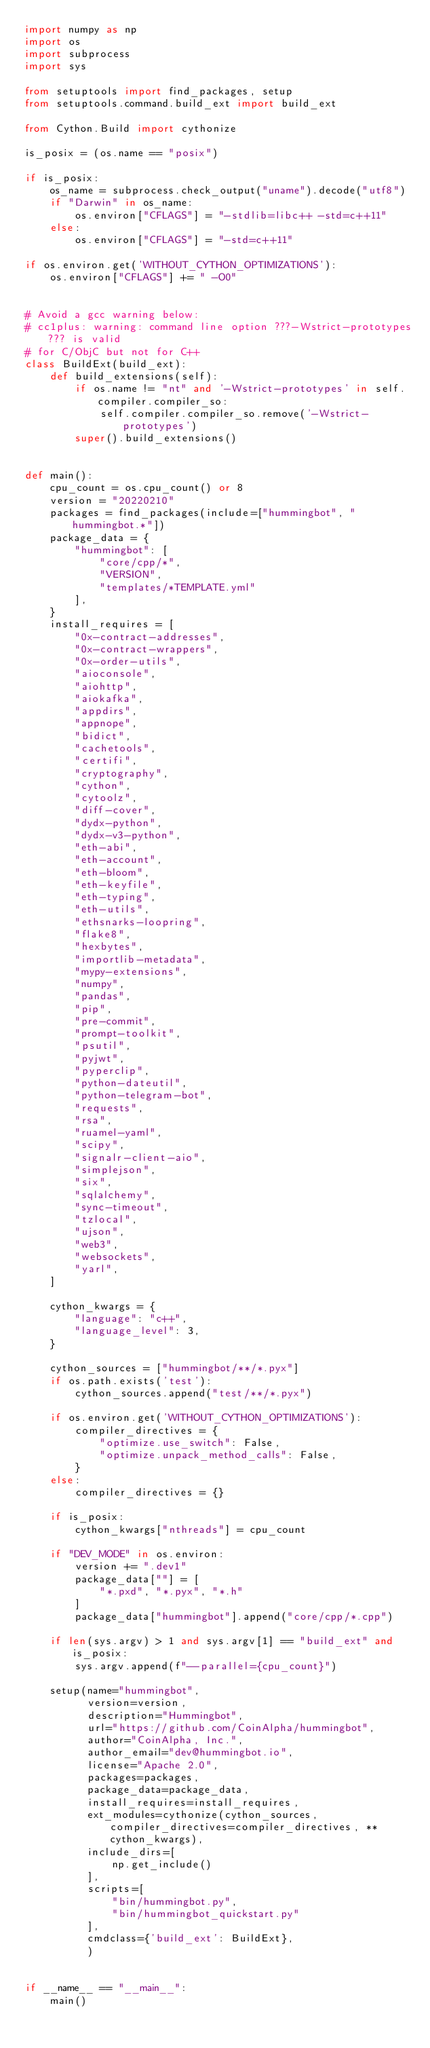<code> <loc_0><loc_0><loc_500><loc_500><_Python_>import numpy as np
import os
import subprocess
import sys

from setuptools import find_packages, setup
from setuptools.command.build_ext import build_ext

from Cython.Build import cythonize

is_posix = (os.name == "posix")

if is_posix:
    os_name = subprocess.check_output("uname").decode("utf8")
    if "Darwin" in os_name:
        os.environ["CFLAGS"] = "-stdlib=libc++ -std=c++11"
    else:
        os.environ["CFLAGS"] = "-std=c++11"

if os.environ.get('WITHOUT_CYTHON_OPTIMIZATIONS'):
    os.environ["CFLAGS"] += " -O0"


# Avoid a gcc warning below:
# cc1plus: warning: command line option ???-Wstrict-prototypes??? is valid
# for C/ObjC but not for C++
class BuildExt(build_ext):
    def build_extensions(self):
        if os.name != "nt" and '-Wstrict-prototypes' in self.compiler.compiler_so:
            self.compiler.compiler_so.remove('-Wstrict-prototypes')
        super().build_extensions()


def main():
    cpu_count = os.cpu_count() or 8
    version = "20220210"
    packages = find_packages(include=["hummingbot", "hummingbot.*"])
    package_data = {
        "hummingbot": [
            "core/cpp/*",
            "VERSION",
            "templates/*TEMPLATE.yml"
        ],
    }
    install_requires = [
        "0x-contract-addresses",
        "0x-contract-wrappers",
        "0x-order-utils",
        "aioconsole",
        "aiohttp",
        "aiokafka",
        "appdirs",
        "appnope",
        "bidict",
        "cachetools",
        "certifi",
        "cryptography",
        "cython",
        "cytoolz",
        "diff-cover",
        "dydx-python",
        "dydx-v3-python",
        "eth-abi",
        "eth-account",
        "eth-bloom",
        "eth-keyfile",
        "eth-typing",
        "eth-utils",
        "ethsnarks-loopring",
        "flake8",
        "hexbytes",
        "importlib-metadata",
        "mypy-extensions",
        "numpy",
        "pandas",
        "pip",
        "pre-commit",
        "prompt-toolkit",
        "psutil",
        "pyjwt",
        "pyperclip",
        "python-dateutil",
        "python-telegram-bot",
        "requests",
        "rsa",
        "ruamel-yaml",
        "scipy",
        "signalr-client-aio",
        "simplejson",
        "six",
        "sqlalchemy",
        "sync-timeout",
        "tzlocal",
        "ujson",
        "web3",
        "websockets",
        "yarl",
    ]

    cython_kwargs = {
        "language": "c++",
        "language_level": 3,
    }

    cython_sources = ["hummingbot/**/*.pyx"]
    if os.path.exists('test'):
        cython_sources.append("test/**/*.pyx")

    if os.environ.get('WITHOUT_CYTHON_OPTIMIZATIONS'):
        compiler_directives = {
            "optimize.use_switch": False,
            "optimize.unpack_method_calls": False,
        }
    else:
        compiler_directives = {}

    if is_posix:
        cython_kwargs["nthreads"] = cpu_count

    if "DEV_MODE" in os.environ:
        version += ".dev1"
        package_data[""] = [
            "*.pxd", "*.pyx", "*.h"
        ]
        package_data["hummingbot"].append("core/cpp/*.cpp")

    if len(sys.argv) > 1 and sys.argv[1] == "build_ext" and is_posix:
        sys.argv.append(f"--parallel={cpu_count}")

    setup(name="hummingbot",
          version=version,
          description="Hummingbot",
          url="https://github.com/CoinAlpha/hummingbot",
          author="CoinAlpha, Inc.",
          author_email="dev@hummingbot.io",
          license="Apache 2.0",
          packages=packages,
          package_data=package_data,
          install_requires=install_requires,
          ext_modules=cythonize(cython_sources, compiler_directives=compiler_directives, **cython_kwargs),
          include_dirs=[
              np.get_include()
          ],
          scripts=[
              "bin/hummingbot.py",
              "bin/hummingbot_quickstart.py"
          ],
          cmdclass={'build_ext': BuildExt},
          )


if __name__ == "__main__":
    main()
</code> 